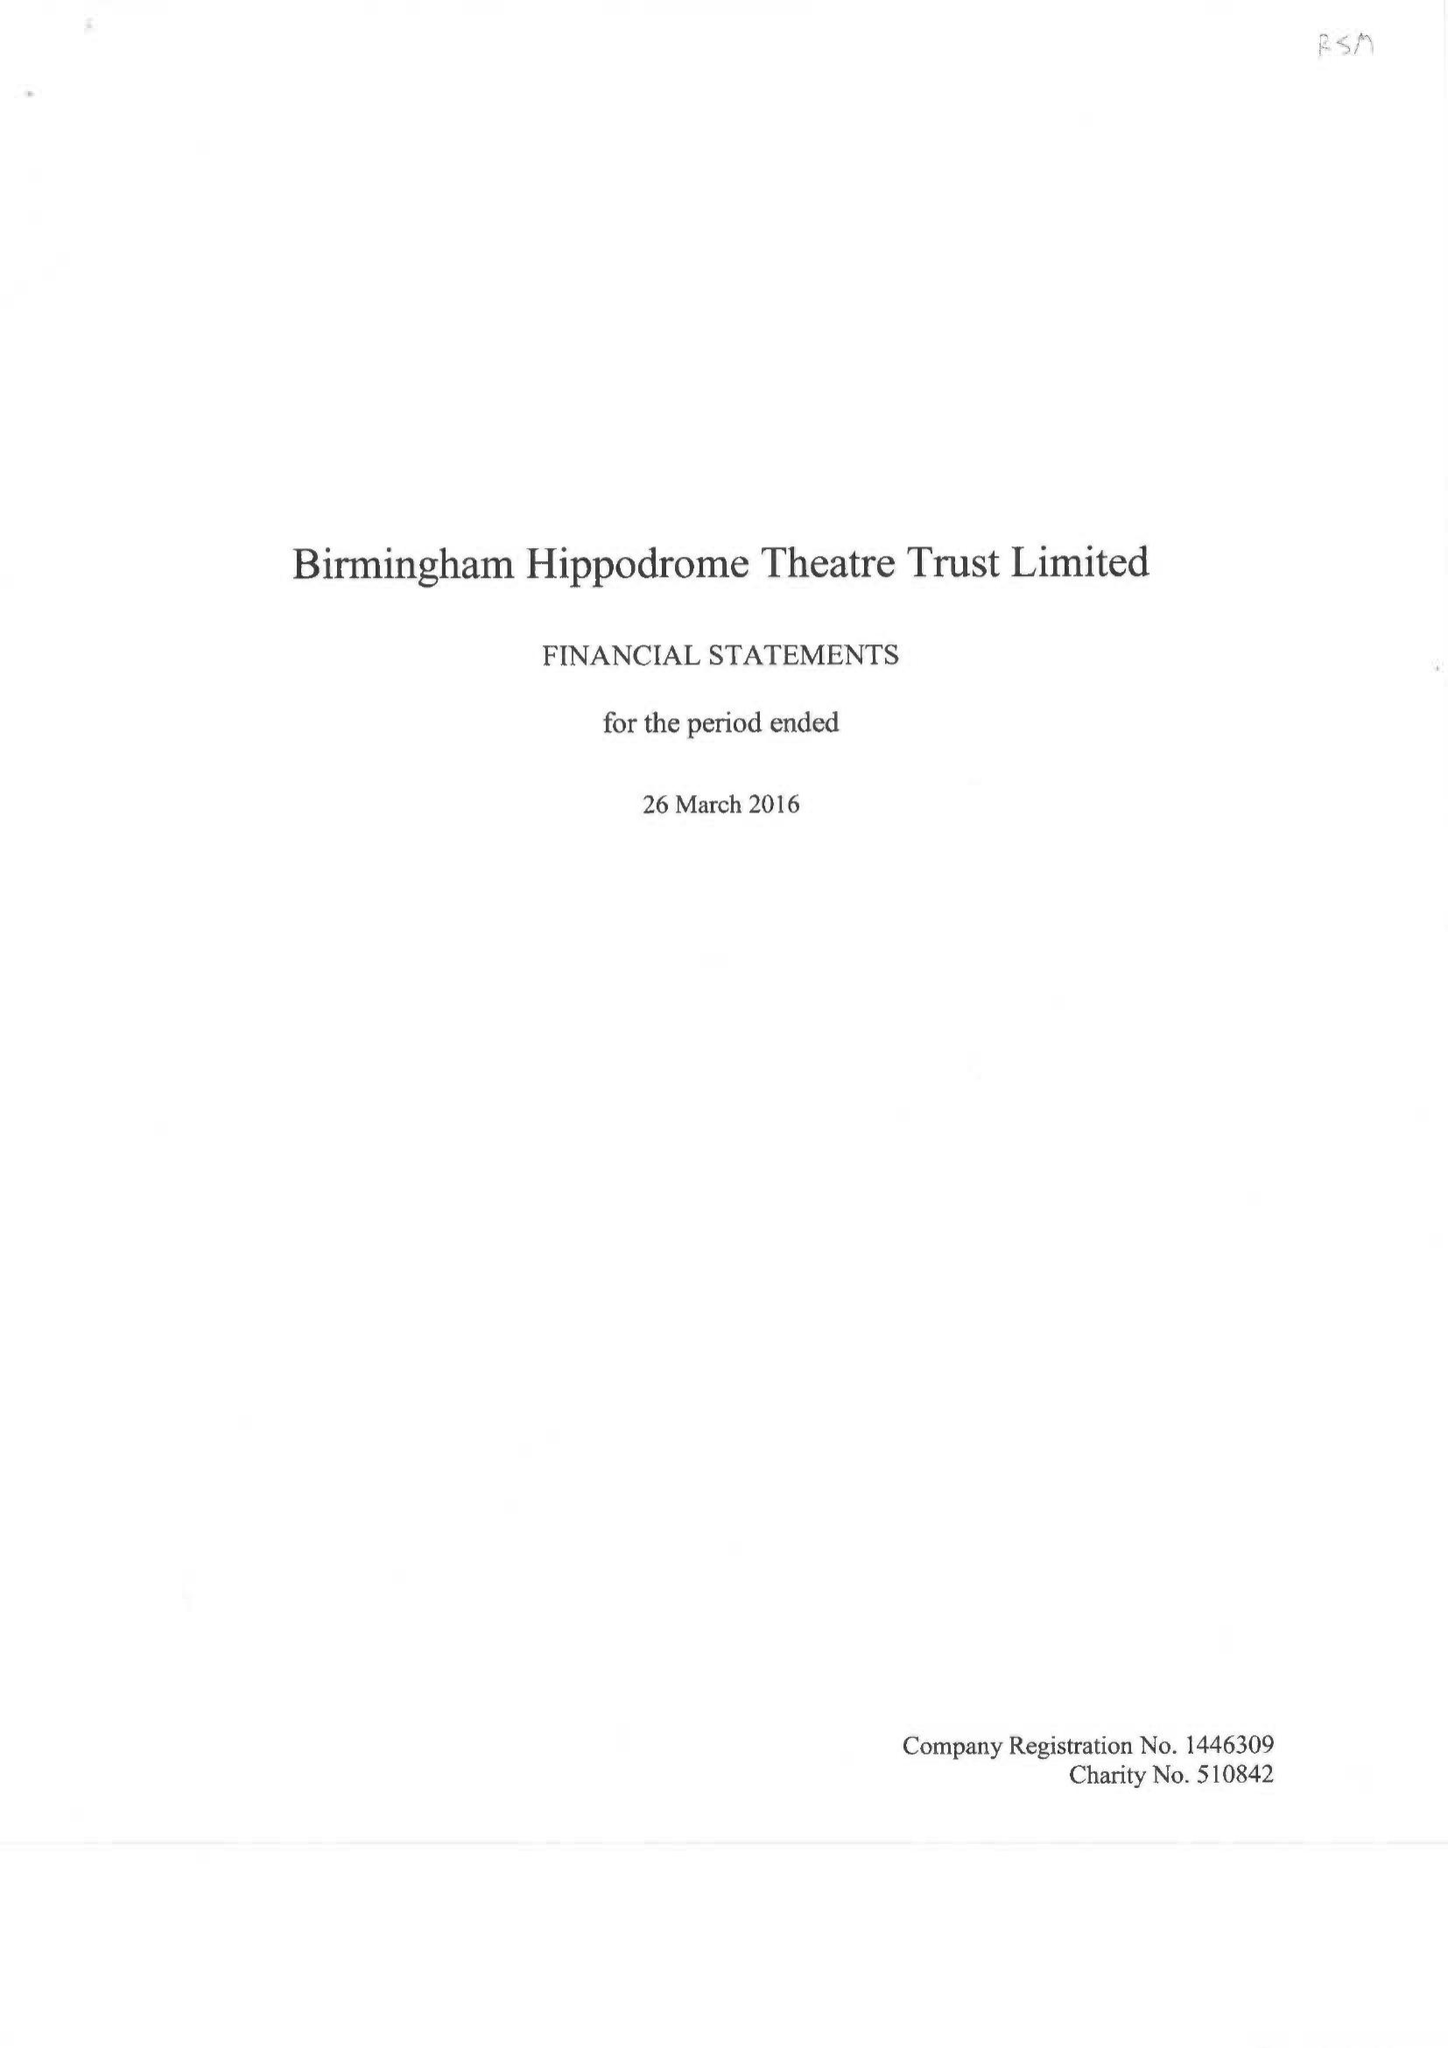What is the value for the address__street_line?
Answer the question using a single word or phrase. HURST STREET 